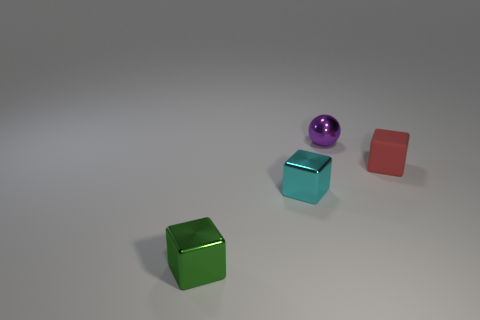Are there any other things that have the same material as the small red thing?
Make the answer very short. No. What number of big purple blocks are there?
Give a very brief answer. 0. Are there fewer metallic objects than tiny green things?
Make the answer very short. No. What is the material of the red thing that is the same size as the cyan metallic cube?
Your response must be concise. Rubber. What number of objects are either blocks or tiny cyan metal objects?
Your answer should be compact. 3. How many shiny things are on the right side of the green block and in front of the matte object?
Your answer should be compact. 1. Is the number of small shiny cubes that are left of the small green thing less than the number of big purple metallic balls?
Provide a succinct answer. No. What shape is the cyan thing that is the same size as the sphere?
Provide a short and direct response. Cube. How many objects are either large blue cubes or small things on the left side of the tiny purple shiny ball?
Offer a terse response. 2. Are there fewer cubes that are on the right side of the tiny red cube than tiny cyan objects on the left side of the tiny purple metallic ball?
Keep it short and to the point. Yes. 